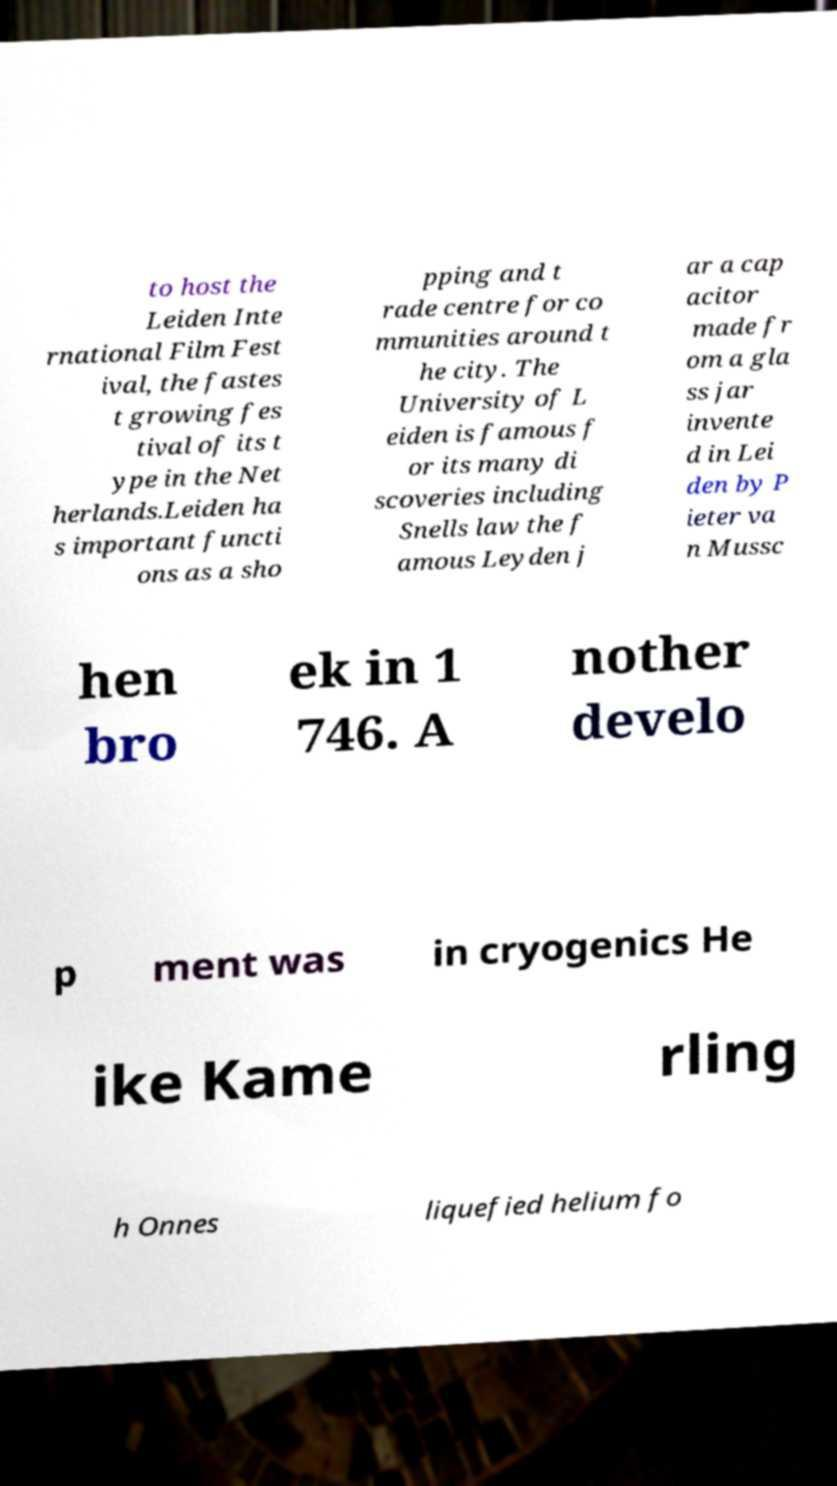Please identify and transcribe the text found in this image. to host the Leiden Inte rnational Film Fest ival, the fastes t growing fes tival of its t ype in the Net herlands.Leiden ha s important functi ons as a sho pping and t rade centre for co mmunities around t he city. The University of L eiden is famous f or its many di scoveries including Snells law the f amous Leyden j ar a cap acitor made fr om a gla ss jar invente d in Lei den by P ieter va n Mussc hen bro ek in 1 746. A nother develo p ment was in cryogenics He ike Kame rling h Onnes liquefied helium fo 